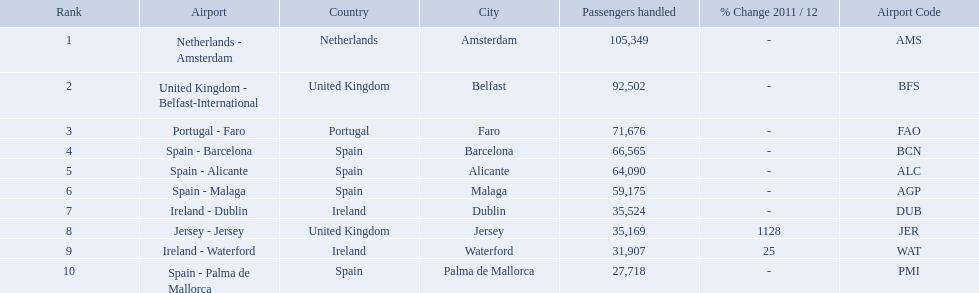What are the airports? Netherlands - Amsterdam, United Kingdom - Belfast-International, Portugal - Faro, Spain - Barcelona, Spain - Alicante, Spain - Malaga, Ireland - Dublin, Jersey - Jersey, Ireland - Waterford, Spain - Palma de Mallorca. Of these which has the least amount of passengers? Spain - Palma de Mallorca. What are the numbers of passengers handled along the different routes in the airport? 105,349, 92,502, 71,676, 66,565, 64,090, 59,175, 35,524, 35,169, 31,907, 27,718. Of these routes, which handles less than 30,000 passengers? Spain - Palma de Mallorca. Name all the london southend airports that did not list a change in 2001/12. Netherlands - Amsterdam, United Kingdom - Belfast-International, Portugal - Faro, Spain - Barcelona, Spain - Alicante, Spain - Malaga, Ireland - Dublin, Spain - Palma de Mallorca. What unchanged percentage airports from 2011/12 handled less then 50,000 passengers? Ireland - Dublin, Spain - Palma de Mallorca. I'm looking to parse the entire table for insights. Could you assist me with that? {'header': ['Rank', 'Airport', 'Country', 'City', 'Passengers handled', '% Change 2011 / 12', 'Airport Code'], 'rows': [['1', 'Netherlands - Amsterdam', 'Netherlands', 'Amsterdam', '105,349', '-', 'AMS'], ['2', 'United Kingdom - Belfast-International', 'United Kingdom', 'Belfast', '92,502', '-', 'BFS'], ['3', 'Portugal - Faro', 'Portugal', 'Faro', '71,676', '-', 'FAO'], ['4', 'Spain - Barcelona', 'Spain', 'Barcelona', '66,565', '-', 'BCN'], ['5', 'Spain - Alicante', 'Spain', 'Alicante', '64,090', '-', 'ALC'], ['6', 'Spain - Malaga', 'Spain', 'Malaga', '59,175', '-', 'AGP'], ['7', 'Ireland - Dublin', 'Ireland', 'Dublin', '35,524', '-', 'DUB'], ['8', 'Jersey - Jersey', 'United Kingdom', 'Jersey', '35,169', '1128', 'JER'], ['9', 'Ireland - Waterford', 'Ireland', 'Waterford', '31,907', '25', 'WAT'], ['10', 'Spain - Palma de Mallorca', 'Spain', 'Palma de Mallorca', '27,718', '-', 'PMI']]} What unchanged percentage airport from 2011/12 handled less then 50,000 passengers is the closest to the equator? Spain - Palma de Mallorca. What are all of the airports? Netherlands - Amsterdam, United Kingdom - Belfast-International, Portugal - Faro, Spain - Barcelona, Spain - Alicante, Spain - Malaga, Ireland - Dublin, Jersey - Jersey, Ireland - Waterford, Spain - Palma de Mallorca. How many passengers have they handled? 105,349, 92,502, 71,676, 66,565, 64,090, 59,175, 35,524, 35,169, 31,907, 27,718. And which airport has handled the most passengers? Netherlands - Amsterdam. What are the 10 busiest routes to and from london southend airport? Netherlands - Amsterdam, United Kingdom - Belfast-International, Portugal - Faro, Spain - Barcelona, Spain - Alicante, Spain - Malaga, Ireland - Dublin, Jersey - Jersey, Ireland - Waterford, Spain - Palma de Mallorca. Of these, which airport is in portugal? Portugal - Faro. What is the highest number of passengers handled? 105,349. What is the destination of the passengers leaving the area that handles 105,349 travellers? Netherlands - Amsterdam. 